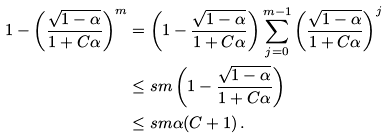<formula> <loc_0><loc_0><loc_500><loc_500>1 - \left ( \frac { \sqrt { 1 - \alpha } } { 1 + C \alpha } \right ) ^ { m } & = \left ( 1 - \frac { \sqrt { 1 - \alpha } } { 1 + C \alpha } \right ) \sum _ { j = 0 } ^ { m - 1 } \left ( \frac { \sqrt { 1 - \alpha } } { 1 + C \alpha } \right ) ^ { j } \\ & \leq s m \left ( 1 - \frac { \sqrt { 1 - \alpha } } { 1 + C \alpha } \right ) \\ & \leq s m \alpha ( C + 1 ) \, .</formula> 